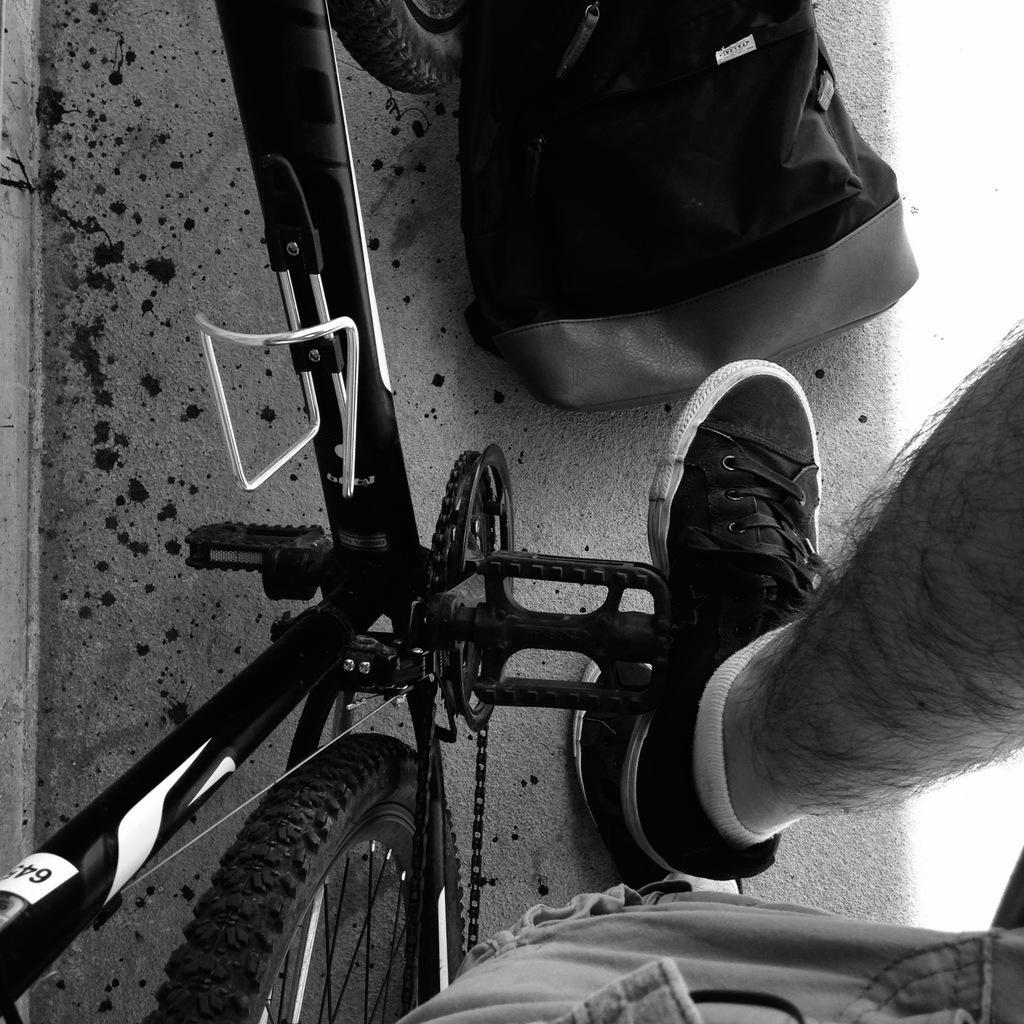How would you summarize this image in a sentence or two? In this picture I can see the truncated image of a cycle and I can see a leg of a person. On the top of this picture I can see a bag and I see the path. 